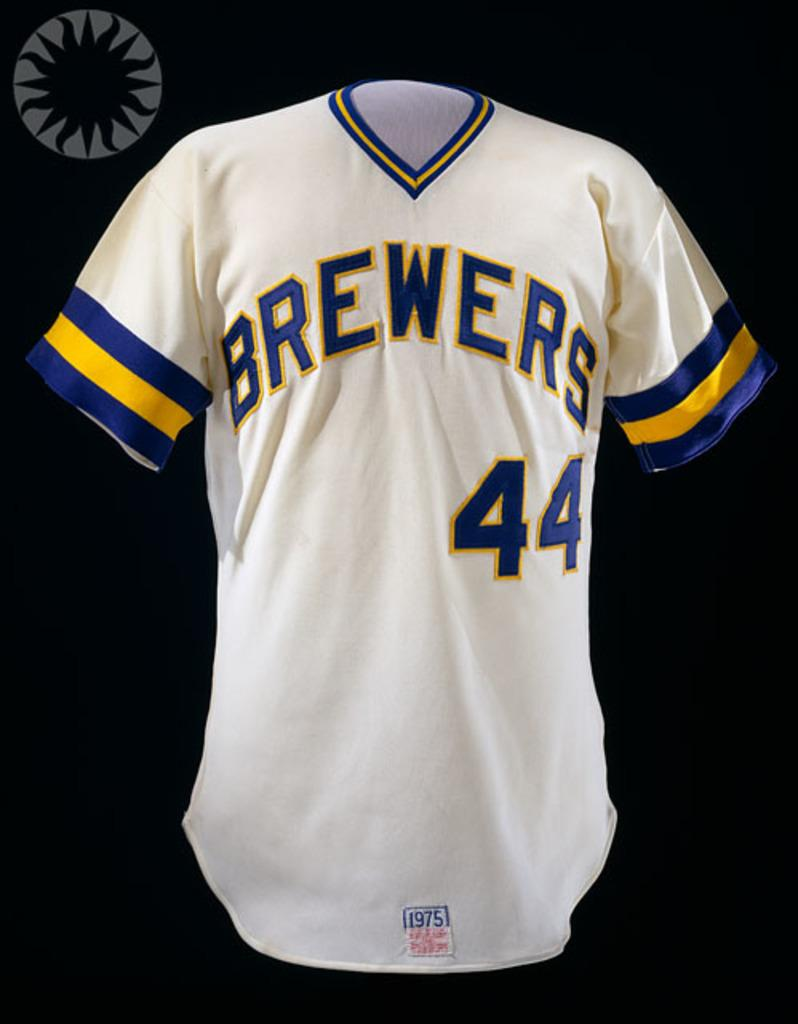<image>
Describe the image concisely. The shirt shown on the black screen is a Brewers top. 